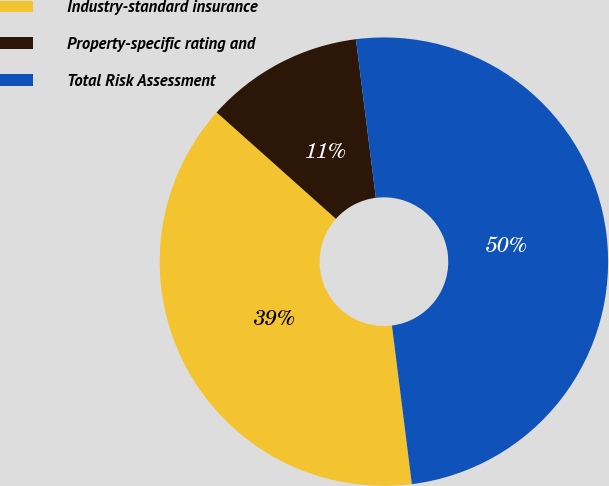Convert chart. <chart><loc_0><loc_0><loc_500><loc_500><pie_chart><fcel>Industry-standard insurance<fcel>Property-specific rating and<fcel>Total Risk Assessment<nl><fcel>38.59%<fcel>11.41%<fcel>50.0%<nl></chart> 